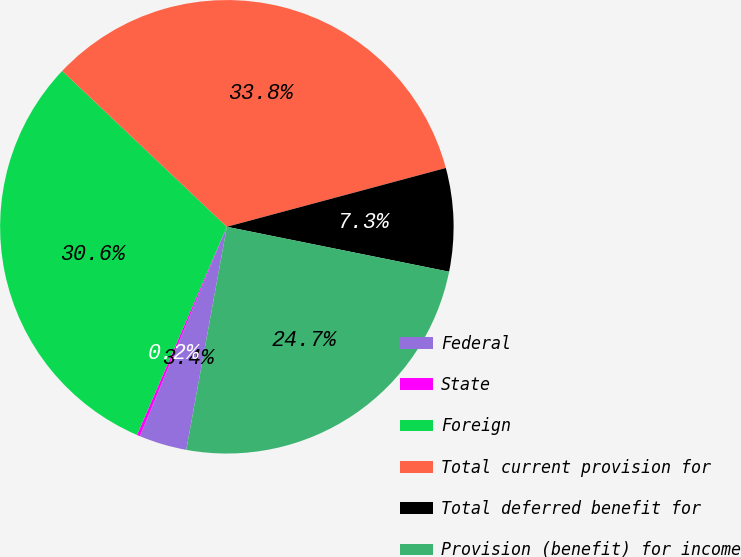Convert chart. <chart><loc_0><loc_0><loc_500><loc_500><pie_chart><fcel>Federal<fcel>State<fcel>Foreign<fcel>Total current provision for<fcel>Total deferred benefit for<fcel>Provision (benefit) for income<nl><fcel>3.4%<fcel>0.22%<fcel>30.58%<fcel>33.76%<fcel>7.35%<fcel>24.69%<nl></chart> 